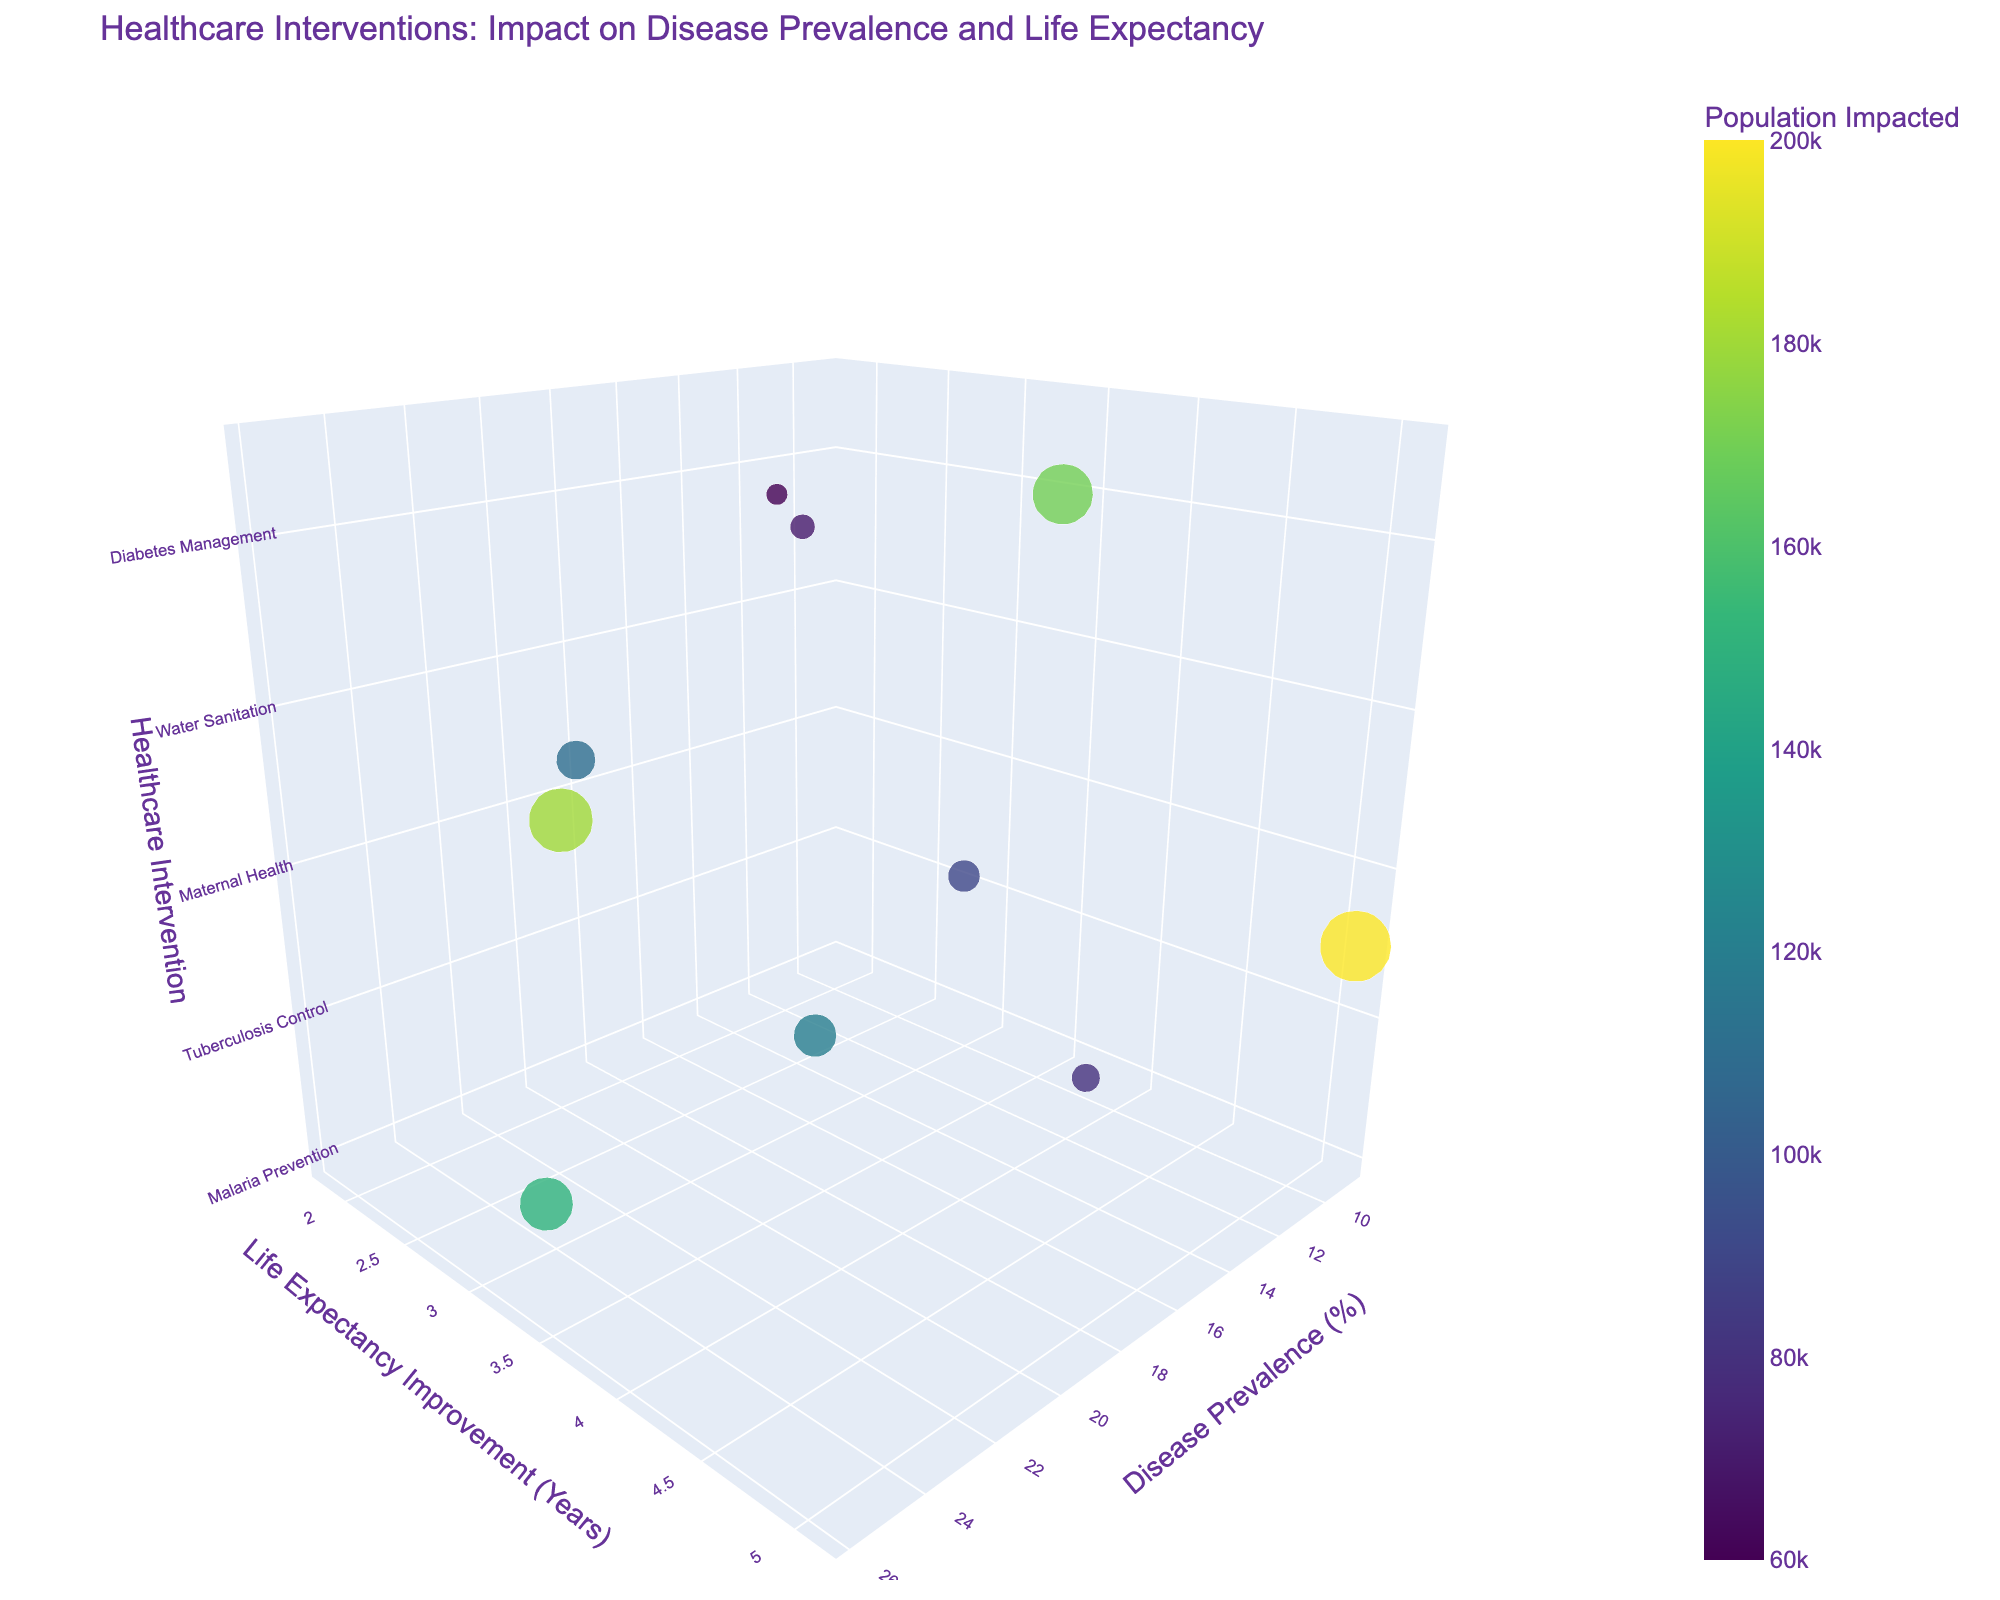What's the title of the chart? The title is usually displayed at the top of the chart. It reads: "Healthcare Interventions: Impact on Disease Prevalence and Life Expectancy".
Answer: Healthcare Interventions: Impact on Disease Prevalence and Life Expectancy What is the range of Disease Prevalence on the x-axis? By looking at the x-axis, we see that the Disease Prevalence ranges from around 8% to 26%.
Answer: 8% to 26% Which healthcare intervention has the largest bubble size? By observing the bubble sizes, we look for the largest one, which corresponds to the "Vaccination Programs" with a Population Impacted of 200,000.
Answer: Vaccination Programs Which intervention provides the highest life expectancy improvement? The y-axis denotes Life Expectancy Improvement. The highest value, 5.1 years, corresponds to the "Vaccination Programs".
Answer: Vaccination Programs How many healthcare interventions are represented in the chart? Each bubble represents one healthcare intervention. Counting the bubbles gives us a total of 10 interventions.
Answer: 10 What is the average Disease Prevalence of all healthcare interventions? The Disease Prevalence values are 23.5, 12.7, 18.3, 8.9, 15.6, 20.1, 25.8, 10.2, 14.5, and 17.9. Summing these values and dividing by the number of interventions (10) gives (23.5+12.7+18.3+8.9+15.6+20.1+25.8+10.2+14.5+17.9)/10 = 16.75%.
Answer: 16.75% Which two interventions have the most similar Disease Prevalence? By comparing Disease Prevalence values, we find "Tuberculosis Control" with 18.3% and "Child Health Programs" with 17.9% to be the most similar.
Answer: Tuberculosis Control and Child Health Programs Compare the Disease Prevalence and Life Expectancy Improvement of "Malaria Prevention" and "Water Sanitation". Which has a greater impact on life expectancy? "Malaria Prevention" has a Disease Prevalence of 23.5% and Life Expectancy Improvement of 2.8 years. "Water Sanitation" has Disease Prevalence of 25.8% and Life Expectancy Improvement of 3.7 years. Thus, "Water Sanitation" has a greater impact on life expectancy.
Answer: Water Sanitation What's the sum of the Population Impacted for "Water Sanitation" and "Child Health Programs"? "Water Sanitation" impacts 180,000, and "Child Health Programs" impacts 170,000. Summing these gives 180,000 + 170,000 = 350,000.
Answer: 350,000 Which intervention has the lowest life expectancy improvement? The y-axis shows "Mental Health Services" has the lowest Life Expectancy Improvement with 1.8 years.
Answer: Mental Health Services 